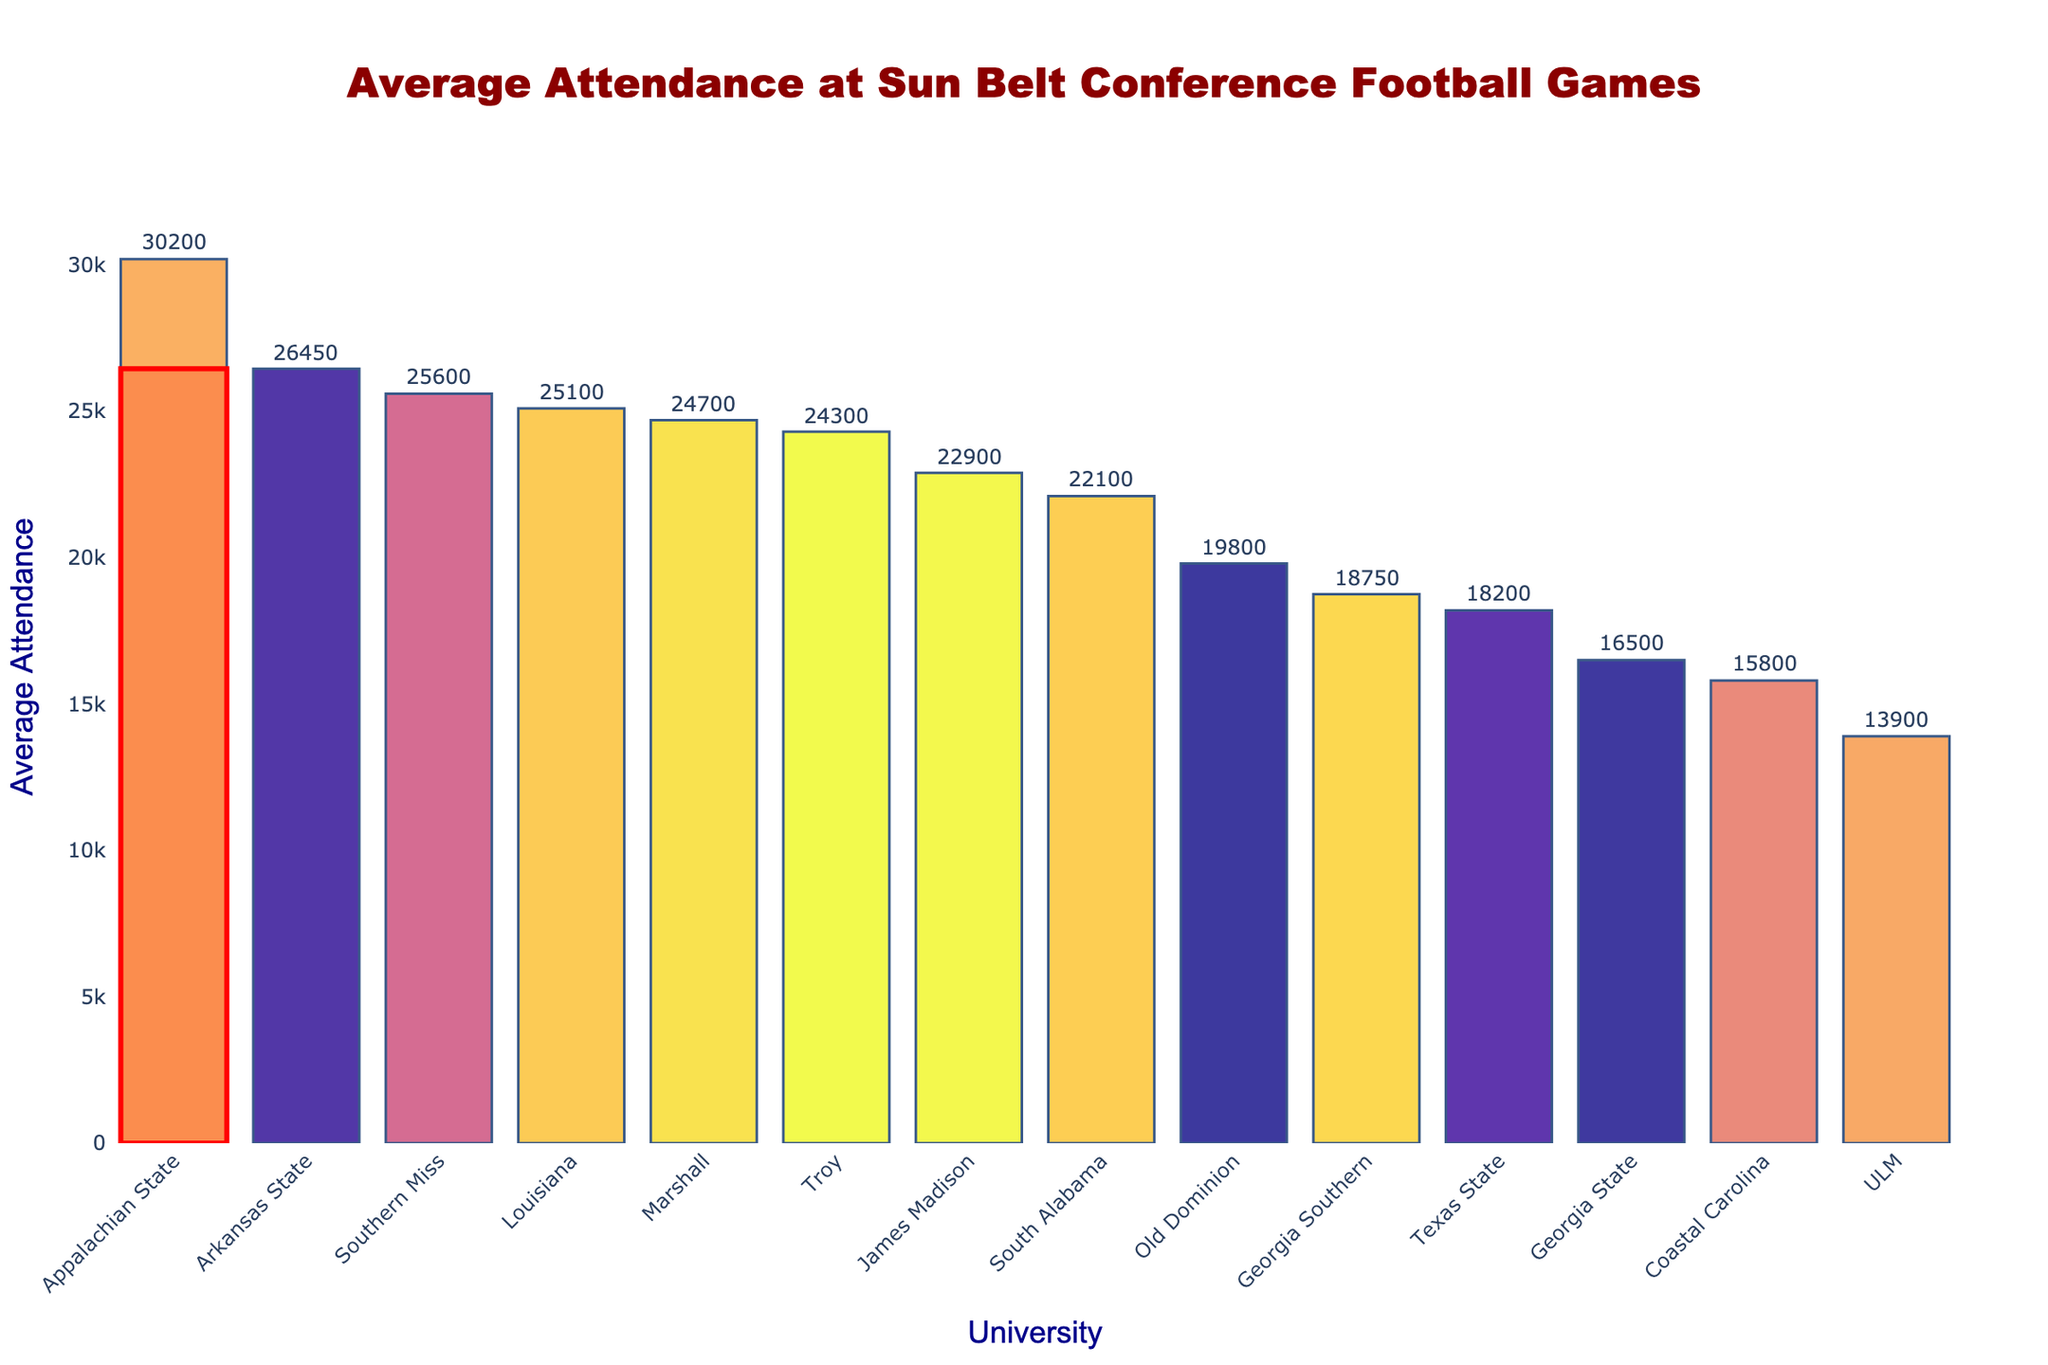How does Arkansas State's average attendance compare to Appalachian State's? Appalachian State has an average attendance of 30,200, while Arkansas State has 26,450. By subtracting Arkansas State's attendance from Appalachian State’s, 30,200 - 26,450 = 3,750, we find that Appalachian State has 3,750 more attendees on average.
Answer: Appalachian State has 3,750 more attendees Which university has the lowest average attendance? From the bar chart, the university with the shortest bar represents the lowest average attendance. For this data, UL Monroe (ULM) has the lowest average attendance at 13,900.
Answer: ULM What is the combined average attendance of Arkansas State, Louisiana, and Southern Miss? We need to add the average attendances of the three universities: 26,450 (Arkansas State) + 25,100 (Louisiana) + 25,600 (Southern Miss) = 77,150.
Answer: 77,150 How many universities have an average attendance higher than 20,000? Counting the bars above the 20,000 mark, the universities are Arkansas State, Appalachian State, Louisiana, Troy, Southern Miss, Old Dominion, James Madison, Marshall, which totals to 8 universities.
Answer: 8 universities What is the average attendance difference between the university with the highest and the lowest attendance? The highest average attendance is Appalachian State at 30,200 and the lowest is ULM at 13,900. Subtracting these values results in 30,200 - 13,900 = 16,300.
Answer: 16,300 Describe the visual representation used to highlight Arkansas State’s bar. Arkansas State’s bar is highlighted with a red-colored rectangle that surrounds it, making it stand out from the rest.
Answer: Red-colored rectangle Which university has the closest average attendance to Arkansas State? Arkansas State's average attendance is 26,450. By scanning the bar chart looking at numbers close to 26,450, the closest is Southern Miss with 25,600, resulting in a difference of 850.
Answer: Southern Miss What’s the median average attendance among all universities? Sorting the average attendance values in ascending order, the list is: 13,900, 15,800, 16,500, 18,200, 18,750, 19,800, 22,100, 22,900, 24,300, 24,700, 25,100, 25,600, 26,450, 30,200. The median is the middle value which is 22,900.
Answer: 22,900 